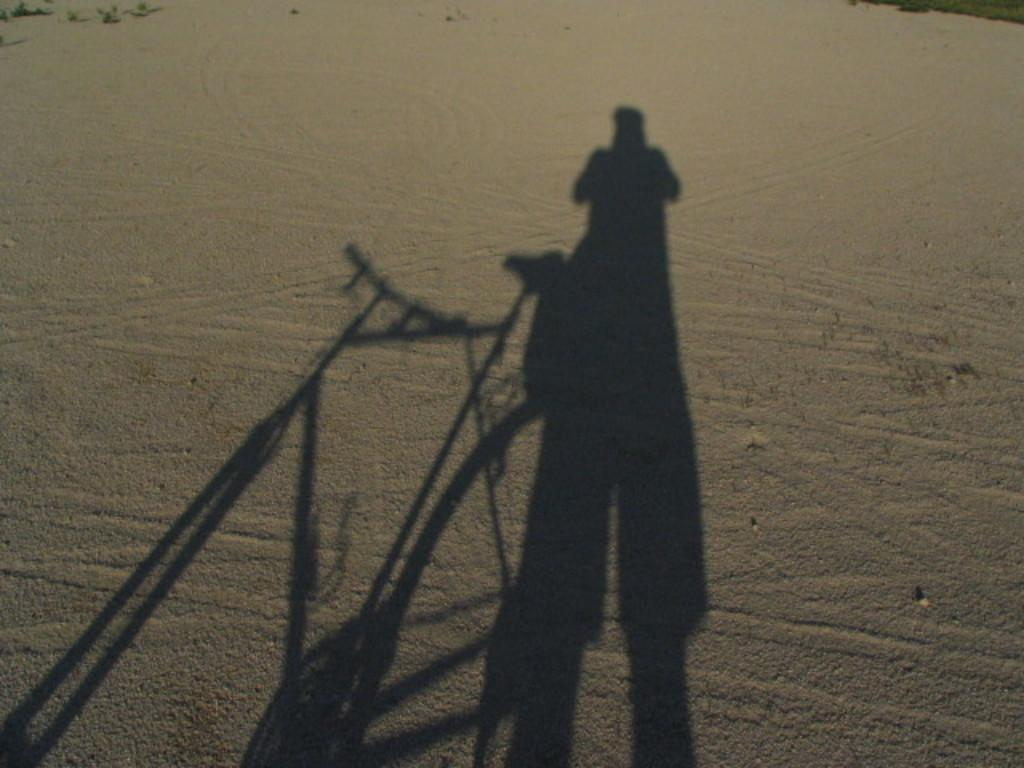What type of environment is shown in the image? The image depicts a desert. Can you describe any vegetation present in the image? There is green grass in the top right corner of the image. What can be seen in the bottom part of the image? There is a shadow of a person and a bicycle at the bottom of the image. How many health bars does the person have in the image? There is no indication of health bars or any gaming elements in the image. 